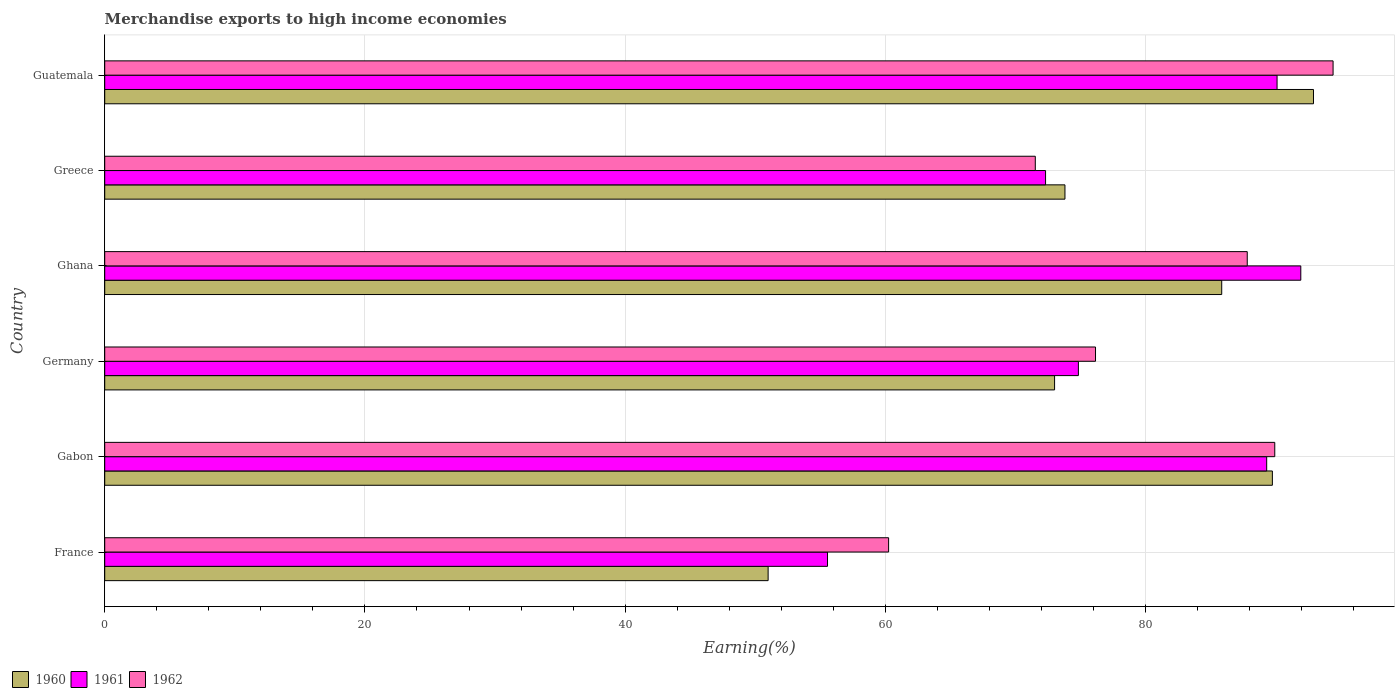How many different coloured bars are there?
Your response must be concise. 3. How many bars are there on the 6th tick from the top?
Make the answer very short. 3. What is the label of the 3rd group of bars from the top?
Provide a succinct answer. Ghana. In how many cases, is the number of bars for a given country not equal to the number of legend labels?
Your answer should be compact. 0. What is the percentage of amount earned from merchandise exports in 1960 in Ghana?
Provide a succinct answer. 85.85. Across all countries, what is the maximum percentage of amount earned from merchandise exports in 1961?
Offer a terse response. 91.93. Across all countries, what is the minimum percentage of amount earned from merchandise exports in 1960?
Your answer should be compact. 50.99. In which country was the percentage of amount earned from merchandise exports in 1961 maximum?
Offer a very short reply. Ghana. In which country was the percentage of amount earned from merchandise exports in 1960 minimum?
Offer a very short reply. France. What is the total percentage of amount earned from merchandise exports in 1961 in the graph?
Offer a very short reply. 474.06. What is the difference between the percentage of amount earned from merchandise exports in 1960 in Germany and that in Guatemala?
Give a very brief answer. -19.9. What is the difference between the percentage of amount earned from merchandise exports in 1962 in Gabon and the percentage of amount earned from merchandise exports in 1961 in France?
Your answer should be very brief. 34.38. What is the average percentage of amount earned from merchandise exports in 1961 per country?
Provide a succinct answer. 79.01. What is the difference between the percentage of amount earned from merchandise exports in 1960 and percentage of amount earned from merchandise exports in 1962 in Germany?
Offer a terse response. -3.15. What is the ratio of the percentage of amount earned from merchandise exports in 1961 in Gabon to that in Greece?
Keep it short and to the point. 1.24. Is the percentage of amount earned from merchandise exports in 1960 in Gabon less than that in Guatemala?
Your response must be concise. Yes. Is the difference between the percentage of amount earned from merchandise exports in 1960 in Greece and Guatemala greater than the difference between the percentage of amount earned from merchandise exports in 1962 in Greece and Guatemala?
Your response must be concise. Yes. What is the difference between the highest and the second highest percentage of amount earned from merchandise exports in 1960?
Provide a succinct answer. 3.16. What is the difference between the highest and the lowest percentage of amount earned from merchandise exports in 1960?
Your answer should be compact. 41.92. What does the 1st bar from the bottom in Greece represents?
Offer a very short reply. 1960. Is it the case that in every country, the sum of the percentage of amount earned from merchandise exports in 1962 and percentage of amount earned from merchandise exports in 1961 is greater than the percentage of amount earned from merchandise exports in 1960?
Your answer should be very brief. Yes. How many bars are there?
Keep it short and to the point. 18. Are all the bars in the graph horizontal?
Make the answer very short. Yes. What is the difference between two consecutive major ticks on the X-axis?
Your answer should be very brief. 20. How are the legend labels stacked?
Keep it short and to the point. Horizontal. What is the title of the graph?
Your answer should be very brief. Merchandise exports to high income economies. Does "1980" appear as one of the legend labels in the graph?
Provide a short and direct response. No. What is the label or title of the X-axis?
Ensure brevity in your answer.  Earning(%). What is the Earning(%) in 1960 in France?
Offer a very short reply. 50.99. What is the Earning(%) in 1961 in France?
Make the answer very short. 55.56. What is the Earning(%) in 1962 in France?
Your answer should be compact. 60.25. What is the Earning(%) in 1960 in Gabon?
Your response must be concise. 89.75. What is the Earning(%) in 1961 in Gabon?
Keep it short and to the point. 89.31. What is the Earning(%) in 1962 in Gabon?
Offer a terse response. 89.93. What is the Earning(%) in 1960 in Germany?
Provide a short and direct response. 73.01. What is the Earning(%) in 1961 in Germany?
Offer a very short reply. 74.84. What is the Earning(%) in 1962 in Germany?
Offer a terse response. 76.15. What is the Earning(%) in 1960 in Ghana?
Give a very brief answer. 85.85. What is the Earning(%) of 1961 in Ghana?
Offer a terse response. 91.93. What is the Earning(%) of 1962 in Ghana?
Offer a terse response. 87.82. What is the Earning(%) in 1960 in Greece?
Offer a very short reply. 73.81. What is the Earning(%) in 1961 in Greece?
Keep it short and to the point. 72.31. What is the Earning(%) in 1962 in Greece?
Ensure brevity in your answer.  71.53. What is the Earning(%) in 1960 in Guatemala?
Make the answer very short. 92.91. What is the Earning(%) in 1961 in Guatemala?
Keep it short and to the point. 90.11. What is the Earning(%) of 1962 in Guatemala?
Make the answer very short. 94.41. Across all countries, what is the maximum Earning(%) of 1960?
Make the answer very short. 92.91. Across all countries, what is the maximum Earning(%) of 1961?
Give a very brief answer. 91.93. Across all countries, what is the maximum Earning(%) of 1962?
Provide a succinct answer. 94.41. Across all countries, what is the minimum Earning(%) of 1960?
Keep it short and to the point. 50.99. Across all countries, what is the minimum Earning(%) in 1961?
Ensure brevity in your answer.  55.56. Across all countries, what is the minimum Earning(%) of 1962?
Provide a short and direct response. 60.25. What is the total Earning(%) in 1960 in the graph?
Keep it short and to the point. 466.32. What is the total Earning(%) of 1961 in the graph?
Offer a very short reply. 474.06. What is the total Earning(%) of 1962 in the graph?
Keep it short and to the point. 480.1. What is the difference between the Earning(%) of 1960 in France and that in Gabon?
Your response must be concise. -38.76. What is the difference between the Earning(%) of 1961 in France and that in Gabon?
Offer a very short reply. -33.76. What is the difference between the Earning(%) in 1962 in France and that in Gabon?
Your response must be concise. -29.68. What is the difference between the Earning(%) of 1960 in France and that in Germany?
Provide a short and direct response. -22.02. What is the difference between the Earning(%) in 1961 in France and that in Germany?
Your answer should be compact. -19.28. What is the difference between the Earning(%) of 1962 in France and that in Germany?
Your response must be concise. -15.9. What is the difference between the Earning(%) in 1960 in France and that in Ghana?
Make the answer very short. -34.86. What is the difference between the Earning(%) of 1961 in France and that in Ghana?
Provide a short and direct response. -36.38. What is the difference between the Earning(%) in 1962 in France and that in Ghana?
Keep it short and to the point. -27.57. What is the difference between the Earning(%) of 1960 in France and that in Greece?
Offer a terse response. -22.81. What is the difference between the Earning(%) of 1961 in France and that in Greece?
Make the answer very short. -16.76. What is the difference between the Earning(%) in 1962 in France and that in Greece?
Offer a very short reply. -11.27. What is the difference between the Earning(%) of 1960 in France and that in Guatemala?
Ensure brevity in your answer.  -41.92. What is the difference between the Earning(%) in 1961 in France and that in Guatemala?
Ensure brevity in your answer.  -34.55. What is the difference between the Earning(%) in 1962 in France and that in Guatemala?
Offer a very short reply. -34.16. What is the difference between the Earning(%) of 1960 in Gabon and that in Germany?
Offer a terse response. 16.74. What is the difference between the Earning(%) of 1961 in Gabon and that in Germany?
Make the answer very short. 14.47. What is the difference between the Earning(%) in 1962 in Gabon and that in Germany?
Your response must be concise. 13.78. What is the difference between the Earning(%) of 1960 in Gabon and that in Ghana?
Offer a terse response. 3.89. What is the difference between the Earning(%) in 1961 in Gabon and that in Ghana?
Provide a succinct answer. -2.62. What is the difference between the Earning(%) of 1962 in Gabon and that in Ghana?
Your response must be concise. 2.11. What is the difference between the Earning(%) of 1960 in Gabon and that in Greece?
Keep it short and to the point. 15.94. What is the difference between the Earning(%) in 1961 in Gabon and that in Greece?
Give a very brief answer. 17. What is the difference between the Earning(%) of 1962 in Gabon and that in Greece?
Your response must be concise. 18.41. What is the difference between the Earning(%) of 1960 in Gabon and that in Guatemala?
Keep it short and to the point. -3.16. What is the difference between the Earning(%) in 1961 in Gabon and that in Guatemala?
Keep it short and to the point. -0.8. What is the difference between the Earning(%) of 1962 in Gabon and that in Guatemala?
Make the answer very short. -4.48. What is the difference between the Earning(%) in 1960 in Germany and that in Ghana?
Give a very brief answer. -12.85. What is the difference between the Earning(%) in 1961 in Germany and that in Ghana?
Keep it short and to the point. -17.09. What is the difference between the Earning(%) of 1962 in Germany and that in Ghana?
Ensure brevity in your answer.  -11.66. What is the difference between the Earning(%) in 1960 in Germany and that in Greece?
Give a very brief answer. -0.8. What is the difference between the Earning(%) in 1961 in Germany and that in Greece?
Your response must be concise. 2.52. What is the difference between the Earning(%) of 1962 in Germany and that in Greece?
Ensure brevity in your answer.  4.63. What is the difference between the Earning(%) in 1960 in Germany and that in Guatemala?
Keep it short and to the point. -19.9. What is the difference between the Earning(%) in 1961 in Germany and that in Guatemala?
Provide a succinct answer. -15.27. What is the difference between the Earning(%) of 1962 in Germany and that in Guatemala?
Offer a terse response. -18.26. What is the difference between the Earning(%) of 1960 in Ghana and that in Greece?
Make the answer very short. 12.05. What is the difference between the Earning(%) in 1961 in Ghana and that in Greece?
Provide a short and direct response. 19.62. What is the difference between the Earning(%) of 1962 in Ghana and that in Greece?
Provide a short and direct response. 16.29. What is the difference between the Earning(%) of 1960 in Ghana and that in Guatemala?
Make the answer very short. -7.05. What is the difference between the Earning(%) of 1961 in Ghana and that in Guatemala?
Your answer should be compact. 1.82. What is the difference between the Earning(%) of 1962 in Ghana and that in Guatemala?
Your answer should be compact. -6.6. What is the difference between the Earning(%) of 1960 in Greece and that in Guatemala?
Ensure brevity in your answer.  -19.1. What is the difference between the Earning(%) in 1961 in Greece and that in Guatemala?
Keep it short and to the point. -17.79. What is the difference between the Earning(%) in 1962 in Greece and that in Guatemala?
Your answer should be very brief. -22.89. What is the difference between the Earning(%) of 1960 in France and the Earning(%) of 1961 in Gabon?
Make the answer very short. -38.32. What is the difference between the Earning(%) in 1960 in France and the Earning(%) in 1962 in Gabon?
Offer a terse response. -38.94. What is the difference between the Earning(%) of 1961 in France and the Earning(%) of 1962 in Gabon?
Your answer should be compact. -34.38. What is the difference between the Earning(%) of 1960 in France and the Earning(%) of 1961 in Germany?
Offer a very short reply. -23.85. What is the difference between the Earning(%) in 1960 in France and the Earning(%) in 1962 in Germany?
Provide a succinct answer. -25.16. What is the difference between the Earning(%) of 1961 in France and the Earning(%) of 1962 in Germany?
Offer a terse response. -20.6. What is the difference between the Earning(%) of 1960 in France and the Earning(%) of 1961 in Ghana?
Your response must be concise. -40.94. What is the difference between the Earning(%) of 1960 in France and the Earning(%) of 1962 in Ghana?
Make the answer very short. -36.83. What is the difference between the Earning(%) of 1961 in France and the Earning(%) of 1962 in Ghana?
Offer a very short reply. -32.26. What is the difference between the Earning(%) of 1960 in France and the Earning(%) of 1961 in Greece?
Offer a terse response. -21.32. What is the difference between the Earning(%) of 1960 in France and the Earning(%) of 1962 in Greece?
Ensure brevity in your answer.  -20.54. What is the difference between the Earning(%) of 1961 in France and the Earning(%) of 1962 in Greece?
Give a very brief answer. -15.97. What is the difference between the Earning(%) of 1960 in France and the Earning(%) of 1961 in Guatemala?
Keep it short and to the point. -39.12. What is the difference between the Earning(%) of 1960 in France and the Earning(%) of 1962 in Guatemala?
Offer a very short reply. -43.42. What is the difference between the Earning(%) of 1961 in France and the Earning(%) of 1962 in Guatemala?
Offer a terse response. -38.86. What is the difference between the Earning(%) in 1960 in Gabon and the Earning(%) in 1961 in Germany?
Your response must be concise. 14.91. What is the difference between the Earning(%) of 1960 in Gabon and the Earning(%) of 1962 in Germany?
Keep it short and to the point. 13.59. What is the difference between the Earning(%) of 1961 in Gabon and the Earning(%) of 1962 in Germany?
Your response must be concise. 13.16. What is the difference between the Earning(%) of 1960 in Gabon and the Earning(%) of 1961 in Ghana?
Provide a short and direct response. -2.18. What is the difference between the Earning(%) of 1960 in Gabon and the Earning(%) of 1962 in Ghana?
Your response must be concise. 1.93. What is the difference between the Earning(%) in 1961 in Gabon and the Earning(%) in 1962 in Ghana?
Provide a short and direct response. 1.49. What is the difference between the Earning(%) in 1960 in Gabon and the Earning(%) in 1961 in Greece?
Offer a very short reply. 17.43. What is the difference between the Earning(%) in 1960 in Gabon and the Earning(%) in 1962 in Greece?
Make the answer very short. 18.22. What is the difference between the Earning(%) of 1961 in Gabon and the Earning(%) of 1962 in Greece?
Keep it short and to the point. 17.79. What is the difference between the Earning(%) in 1960 in Gabon and the Earning(%) in 1961 in Guatemala?
Give a very brief answer. -0.36. What is the difference between the Earning(%) of 1960 in Gabon and the Earning(%) of 1962 in Guatemala?
Provide a short and direct response. -4.67. What is the difference between the Earning(%) in 1961 in Gabon and the Earning(%) in 1962 in Guatemala?
Give a very brief answer. -5.1. What is the difference between the Earning(%) in 1960 in Germany and the Earning(%) in 1961 in Ghana?
Your answer should be compact. -18.93. What is the difference between the Earning(%) of 1960 in Germany and the Earning(%) of 1962 in Ghana?
Make the answer very short. -14.81. What is the difference between the Earning(%) of 1961 in Germany and the Earning(%) of 1962 in Ghana?
Your response must be concise. -12.98. What is the difference between the Earning(%) in 1960 in Germany and the Earning(%) in 1961 in Greece?
Ensure brevity in your answer.  0.69. What is the difference between the Earning(%) in 1960 in Germany and the Earning(%) in 1962 in Greece?
Your answer should be very brief. 1.48. What is the difference between the Earning(%) of 1961 in Germany and the Earning(%) of 1962 in Greece?
Your answer should be very brief. 3.31. What is the difference between the Earning(%) of 1960 in Germany and the Earning(%) of 1961 in Guatemala?
Offer a terse response. -17.1. What is the difference between the Earning(%) of 1960 in Germany and the Earning(%) of 1962 in Guatemala?
Your answer should be very brief. -21.41. What is the difference between the Earning(%) of 1961 in Germany and the Earning(%) of 1962 in Guatemala?
Your response must be concise. -19.58. What is the difference between the Earning(%) in 1960 in Ghana and the Earning(%) in 1961 in Greece?
Offer a very short reply. 13.54. What is the difference between the Earning(%) of 1960 in Ghana and the Earning(%) of 1962 in Greece?
Provide a succinct answer. 14.33. What is the difference between the Earning(%) of 1961 in Ghana and the Earning(%) of 1962 in Greece?
Your answer should be very brief. 20.41. What is the difference between the Earning(%) in 1960 in Ghana and the Earning(%) in 1961 in Guatemala?
Offer a very short reply. -4.25. What is the difference between the Earning(%) in 1960 in Ghana and the Earning(%) in 1962 in Guatemala?
Ensure brevity in your answer.  -8.56. What is the difference between the Earning(%) in 1961 in Ghana and the Earning(%) in 1962 in Guatemala?
Offer a very short reply. -2.48. What is the difference between the Earning(%) in 1960 in Greece and the Earning(%) in 1961 in Guatemala?
Provide a succinct answer. -16.3. What is the difference between the Earning(%) in 1960 in Greece and the Earning(%) in 1962 in Guatemala?
Your answer should be compact. -20.61. What is the difference between the Earning(%) in 1961 in Greece and the Earning(%) in 1962 in Guatemala?
Make the answer very short. -22.1. What is the average Earning(%) in 1960 per country?
Keep it short and to the point. 77.72. What is the average Earning(%) in 1961 per country?
Provide a short and direct response. 79.01. What is the average Earning(%) in 1962 per country?
Give a very brief answer. 80.02. What is the difference between the Earning(%) of 1960 and Earning(%) of 1961 in France?
Provide a succinct answer. -4.56. What is the difference between the Earning(%) in 1960 and Earning(%) in 1962 in France?
Offer a very short reply. -9.26. What is the difference between the Earning(%) of 1961 and Earning(%) of 1962 in France?
Provide a short and direct response. -4.7. What is the difference between the Earning(%) in 1960 and Earning(%) in 1961 in Gabon?
Your answer should be compact. 0.44. What is the difference between the Earning(%) of 1960 and Earning(%) of 1962 in Gabon?
Provide a succinct answer. -0.18. What is the difference between the Earning(%) of 1961 and Earning(%) of 1962 in Gabon?
Offer a terse response. -0.62. What is the difference between the Earning(%) in 1960 and Earning(%) in 1961 in Germany?
Make the answer very short. -1.83. What is the difference between the Earning(%) of 1960 and Earning(%) of 1962 in Germany?
Provide a short and direct response. -3.15. What is the difference between the Earning(%) in 1961 and Earning(%) in 1962 in Germany?
Offer a terse response. -1.32. What is the difference between the Earning(%) in 1960 and Earning(%) in 1961 in Ghana?
Make the answer very short. -6.08. What is the difference between the Earning(%) of 1960 and Earning(%) of 1962 in Ghana?
Make the answer very short. -1.96. What is the difference between the Earning(%) of 1961 and Earning(%) of 1962 in Ghana?
Offer a terse response. 4.12. What is the difference between the Earning(%) of 1960 and Earning(%) of 1961 in Greece?
Offer a very short reply. 1.49. What is the difference between the Earning(%) of 1960 and Earning(%) of 1962 in Greece?
Make the answer very short. 2.28. What is the difference between the Earning(%) in 1961 and Earning(%) in 1962 in Greece?
Your answer should be compact. 0.79. What is the difference between the Earning(%) of 1960 and Earning(%) of 1961 in Guatemala?
Provide a succinct answer. 2.8. What is the difference between the Earning(%) of 1960 and Earning(%) of 1962 in Guatemala?
Give a very brief answer. -1.51. What is the difference between the Earning(%) in 1961 and Earning(%) in 1962 in Guatemala?
Provide a short and direct response. -4.3. What is the ratio of the Earning(%) of 1960 in France to that in Gabon?
Your answer should be very brief. 0.57. What is the ratio of the Earning(%) in 1961 in France to that in Gabon?
Provide a succinct answer. 0.62. What is the ratio of the Earning(%) of 1962 in France to that in Gabon?
Give a very brief answer. 0.67. What is the ratio of the Earning(%) in 1960 in France to that in Germany?
Offer a terse response. 0.7. What is the ratio of the Earning(%) of 1961 in France to that in Germany?
Offer a very short reply. 0.74. What is the ratio of the Earning(%) in 1962 in France to that in Germany?
Provide a succinct answer. 0.79. What is the ratio of the Earning(%) of 1960 in France to that in Ghana?
Your response must be concise. 0.59. What is the ratio of the Earning(%) of 1961 in France to that in Ghana?
Provide a succinct answer. 0.6. What is the ratio of the Earning(%) of 1962 in France to that in Ghana?
Your answer should be very brief. 0.69. What is the ratio of the Earning(%) of 1960 in France to that in Greece?
Ensure brevity in your answer.  0.69. What is the ratio of the Earning(%) in 1961 in France to that in Greece?
Your response must be concise. 0.77. What is the ratio of the Earning(%) of 1962 in France to that in Greece?
Keep it short and to the point. 0.84. What is the ratio of the Earning(%) in 1960 in France to that in Guatemala?
Your answer should be compact. 0.55. What is the ratio of the Earning(%) in 1961 in France to that in Guatemala?
Keep it short and to the point. 0.62. What is the ratio of the Earning(%) in 1962 in France to that in Guatemala?
Your answer should be compact. 0.64. What is the ratio of the Earning(%) of 1960 in Gabon to that in Germany?
Give a very brief answer. 1.23. What is the ratio of the Earning(%) of 1961 in Gabon to that in Germany?
Provide a succinct answer. 1.19. What is the ratio of the Earning(%) of 1962 in Gabon to that in Germany?
Your answer should be very brief. 1.18. What is the ratio of the Earning(%) in 1960 in Gabon to that in Ghana?
Your answer should be very brief. 1.05. What is the ratio of the Earning(%) of 1961 in Gabon to that in Ghana?
Ensure brevity in your answer.  0.97. What is the ratio of the Earning(%) in 1962 in Gabon to that in Ghana?
Provide a short and direct response. 1.02. What is the ratio of the Earning(%) of 1960 in Gabon to that in Greece?
Offer a terse response. 1.22. What is the ratio of the Earning(%) of 1961 in Gabon to that in Greece?
Offer a very short reply. 1.24. What is the ratio of the Earning(%) in 1962 in Gabon to that in Greece?
Provide a short and direct response. 1.26. What is the ratio of the Earning(%) of 1960 in Gabon to that in Guatemala?
Provide a succinct answer. 0.97. What is the ratio of the Earning(%) in 1962 in Gabon to that in Guatemala?
Your answer should be compact. 0.95. What is the ratio of the Earning(%) in 1960 in Germany to that in Ghana?
Your answer should be compact. 0.85. What is the ratio of the Earning(%) of 1961 in Germany to that in Ghana?
Ensure brevity in your answer.  0.81. What is the ratio of the Earning(%) of 1962 in Germany to that in Ghana?
Offer a very short reply. 0.87. What is the ratio of the Earning(%) of 1961 in Germany to that in Greece?
Offer a very short reply. 1.03. What is the ratio of the Earning(%) in 1962 in Germany to that in Greece?
Keep it short and to the point. 1.06. What is the ratio of the Earning(%) of 1960 in Germany to that in Guatemala?
Keep it short and to the point. 0.79. What is the ratio of the Earning(%) of 1961 in Germany to that in Guatemala?
Offer a terse response. 0.83. What is the ratio of the Earning(%) in 1962 in Germany to that in Guatemala?
Give a very brief answer. 0.81. What is the ratio of the Earning(%) in 1960 in Ghana to that in Greece?
Offer a very short reply. 1.16. What is the ratio of the Earning(%) in 1961 in Ghana to that in Greece?
Keep it short and to the point. 1.27. What is the ratio of the Earning(%) of 1962 in Ghana to that in Greece?
Offer a very short reply. 1.23. What is the ratio of the Earning(%) of 1960 in Ghana to that in Guatemala?
Ensure brevity in your answer.  0.92. What is the ratio of the Earning(%) of 1961 in Ghana to that in Guatemala?
Provide a succinct answer. 1.02. What is the ratio of the Earning(%) of 1962 in Ghana to that in Guatemala?
Offer a very short reply. 0.93. What is the ratio of the Earning(%) of 1960 in Greece to that in Guatemala?
Provide a short and direct response. 0.79. What is the ratio of the Earning(%) in 1961 in Greece to that in Guatemala?
Offer a very short reply. 0.8. What is the ratio of the Earning(%) of 1962 in Greece to that in Guatemala?
Give a very brief answer. 0.76. What is the difference between the highest and the second highest Earning(%) in 1960?
Offer a very short reply. 3.16. What is the difference between the highest and the second highest Earning(%) of 1961?
Offer a very short reply. 1.82. What is the difference between the highest and the second highest Earning(%) of 1962?
Keep it short and to the point. 4.48. What is the difference between the highest and the lowest Earning(%) of 1960?
Offer a terse response. 41.92. What is the difference between the highest and the lowest Earning(%) in 1961?
Offer a terse response. 36.38. What is the difference between the highest and the lowest Earning(%) of 1962?
Offer a very short reply. 34.16. 